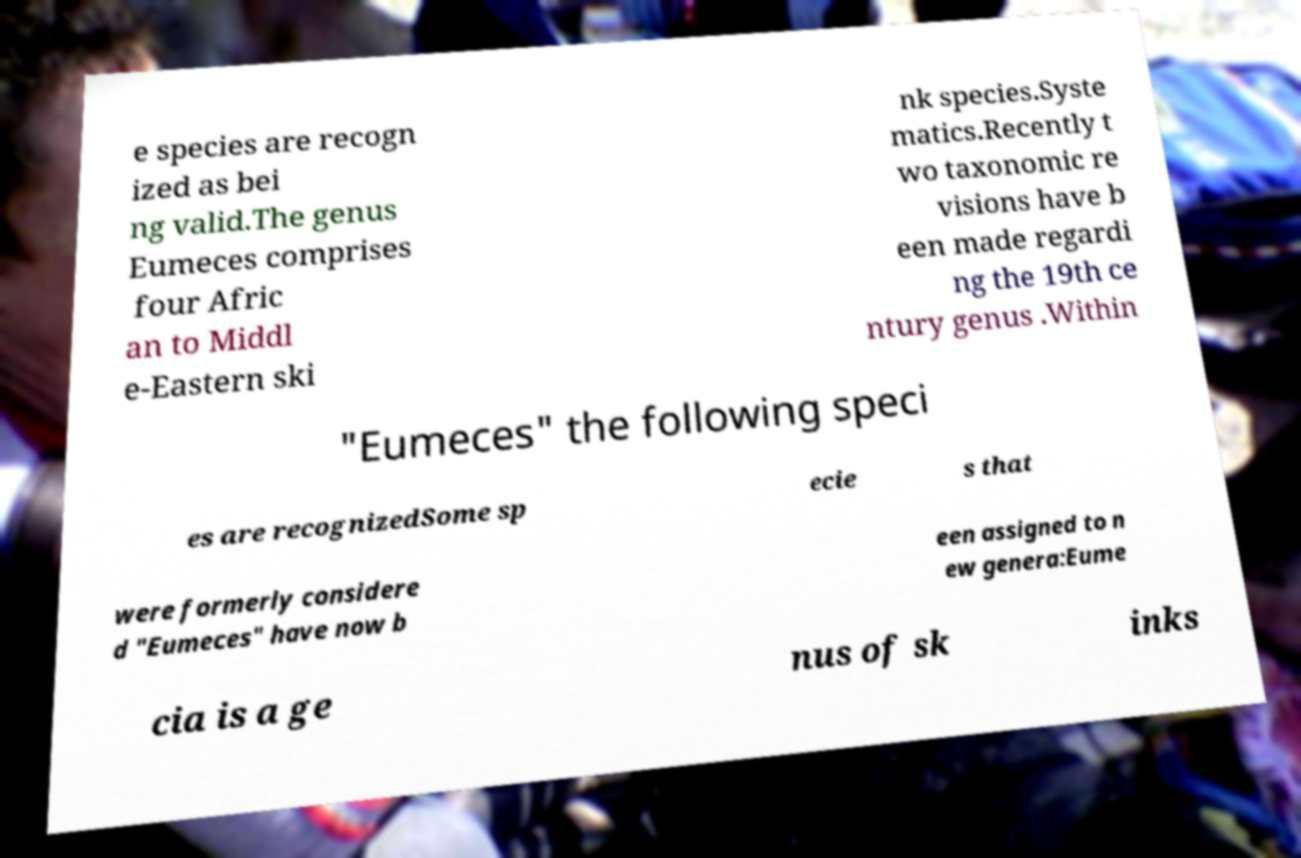I need the written content from this picture converted into text. Can you do that? e species are recogn ized as bei ng valid.The genus Eumeces comprises four Afric an to Middl e-Eastern ski nk species.Syste matics.Recently t wo taxonomic re visions have b een made regardi ng the 19th ce ntury genus .Within "Eumeces" the following speci es are recognizedSome sp ecie s that were formerly considere d "Eumeces" have now b een assigned to n ew genera:Eume cia is a ge nus of sk inks 